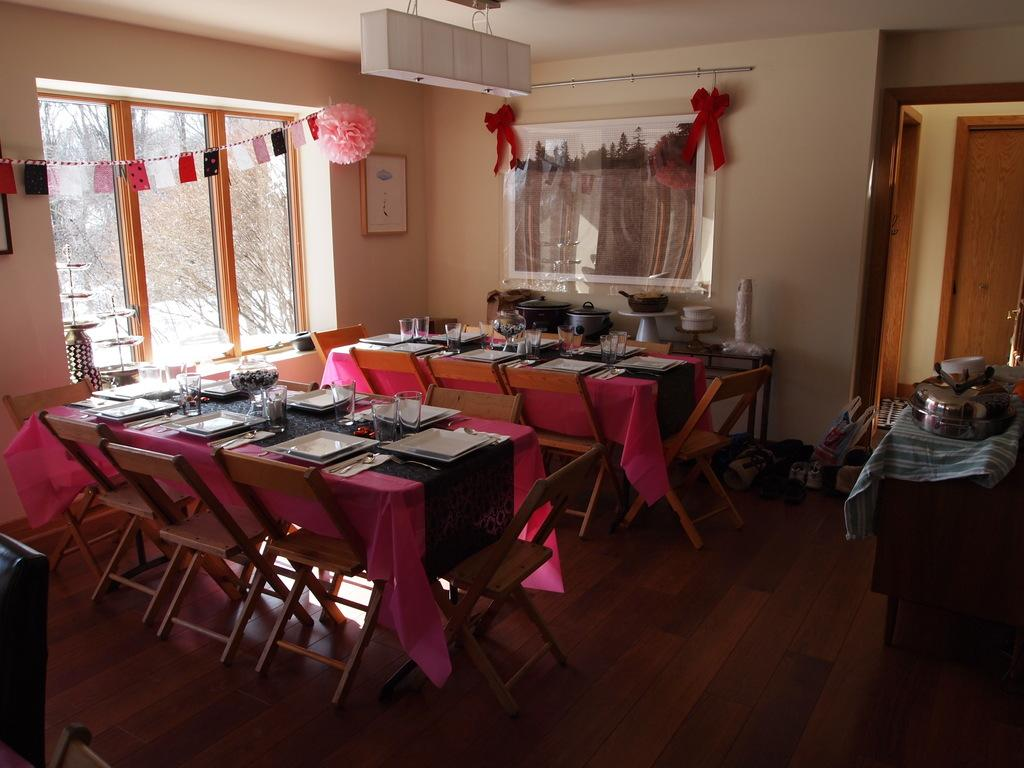What types of objects are present on the tables in the image? There are plates, glasses, bowls, and utensils on the tables in the image. Can you describe the background of the image? There is a wall, a window, a door, a photo frame, and trees in the background of the image. What might be the setting of the image? The image may have been taken in a hall. How many islands can be seen in the image? There are no islands present in the image. What type of tree is growing in the photo frame in the image? There is no tree growing in the photo frame in the image. 